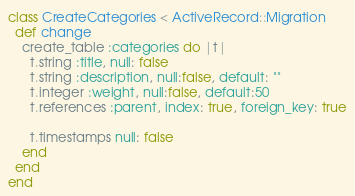Convert code to text. <code><loc_0><loc_0><loc_500><loc_500><_Ruby_>class CreateCategories < ActiveRecord::Migration
  def change
    create_table :categories do |t|
      t.string :title, null: false
      t.string :description, null:false, default: ""
      t.integer :weight, null:false, default:50
      t.references :parent, index: true, foreign_key: true

      t.timestamps null: false
    end
  end
end
</code> 